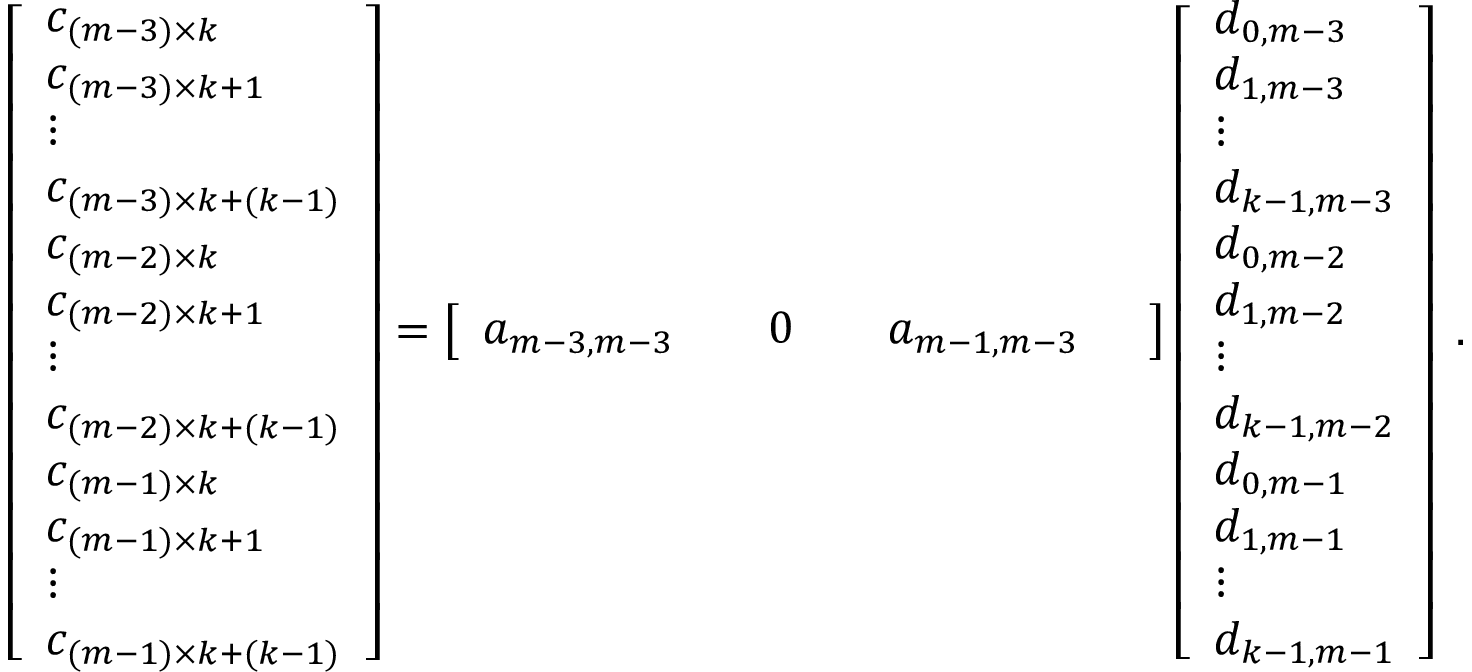Convert formula to latex. <formula><loc_0><loc_0><loc_500><loc_500>\begin{array} { r } { \left [ \begin{array} { l } { c _ { ( m - 3 ) \times k } } \\ { c _ { ( m - 3 ) \times k + 1 } } \\ { \vdots } \\ { c _ { ( m - 3 ) \times k + ( k - 1 ) } } \\ { c _ { ( m - 2 ) \times k } } \\ { c _ { ( m - 2 ) \times k + 1 } } \\ { \vdots } \\ { c _ { ( m - 2 ) \times k + ( k - 1 ) } } \\ { c _ { ( m - 1 ) \times k } } \\ { c _ { ( m - 1 ) \times k + 1 } } \\ { \vdots } \\ { c _ { ( m - 1 ) \times k + ( k - 1 ) } } \end{array} \right ] = \left [ \begin{array} { l l l l l l } { a _ { m - 3 , m - 3 } } & { 0 } & { a _ { m - 1 , m - 3 } } \end{array} \right ] \left [ \begin{array} { l } { d _ { 0 , m - 3 } } \\ { d _ { 1 , m - 3 } } \\ { \vdots } \\ { d _ { k - 1 , m - 3 } } \\ { d _ { 0 , m - 2 } } \\ { d _ { 1 , m - 2 } } \\ { \vdots } \\ { d _ { k - 1 , m - 2 } } \\ { d _ { 0 , m - 1 } } \\ { d _ { 1 , m - 1 } } \\ { \vdots } \\ { d _ { k - 1 , m - 1 } } \end{array} \right ] \, . } \end{array}</formula> 